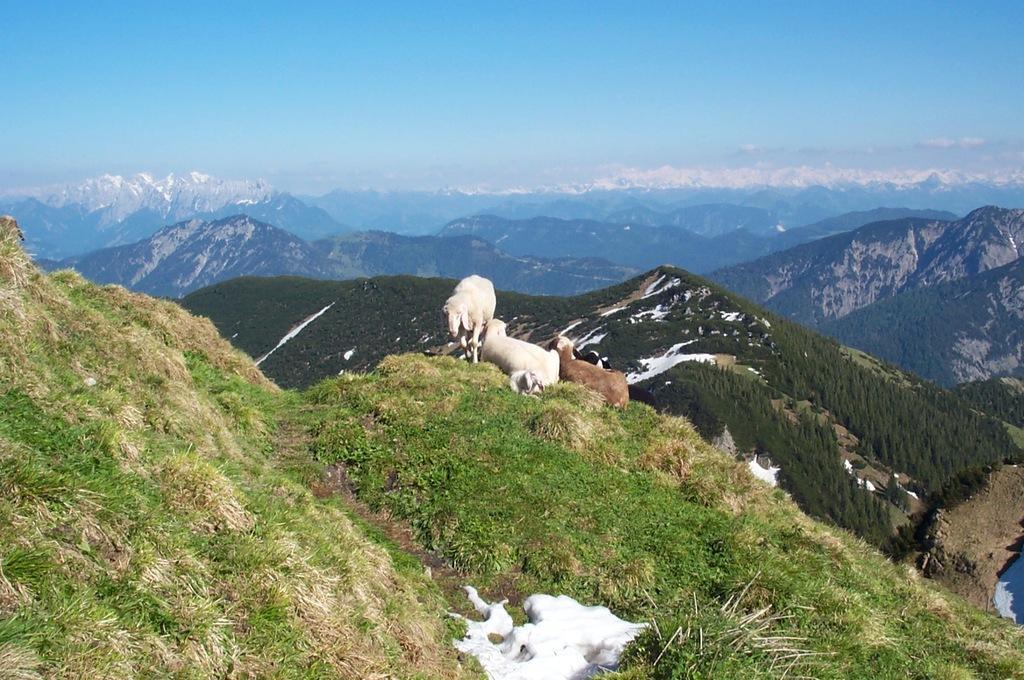How would you summarize this image in a sentence or two? In this image we can see three sheep on the grass. In the background, we can see hills, mountains and sky. 